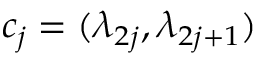Convert formula to latex. <formula><loc_0><loc_0><loc_500><loc_500>c _ { j } = ( \lambda _ { 2 j } , \lambda _ { 2 j + 1 } )</formula> 